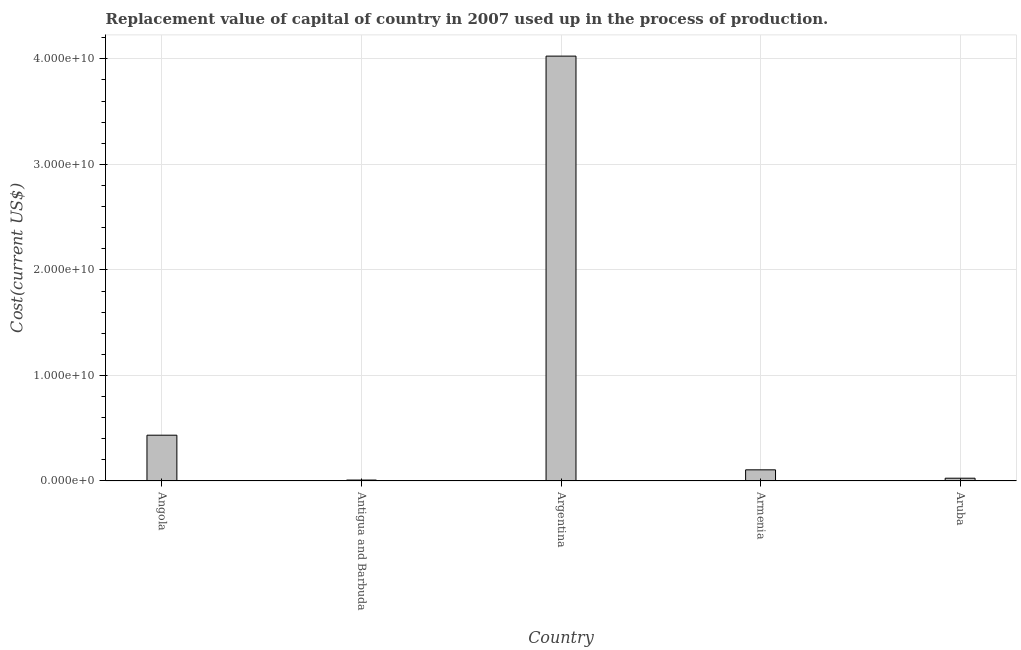What is the title of the graph?
Your answer should be compact. Replacement value of capital of country in 2007 used up in the process of production. What is the label or title of the Y-axis?
Your answer should be compact. Cost(current US$). What is the consumption of fixed capital in Armenia?
Offer a very short reply. 1.06e+09. Across all countries, what is the maximum consumption of fixed capital?
Your answer should be very brief. 4.03e+1. Across all countries, what is the minimum consumption of fixed capital?
Offer a very short reply. 8.85e+07. In which country was the consumption of fixed capital minimum?
Keep it short and to the point. Antigua and Barbuda. What is the sum of the consumption of fixed capital?
Make the answer very short. 4.60e+1. What is the difference between the consumption of fixed capital in Angola and Argentina?
Offer a very short reply. -3.59e+1. What is the average consumption of fixed capital per country?
Offer a terse response. 9.20e+09. What is the median consumption of fixed capital?
Ensure brevity in your answer.  1.06e+09. In how many countries, is the consumption of fixed capital greater than 8000000000 US$?
Offer a very short reply. 1. What is the ratio of the consumption of fixed capital in Argentina to that in Armenia?
Give a very brief answer. 38.05. What is the difference between the highest and the second highest consumption of fixed capital?
Provide a short and direct response. 3.59e+1. Is the sum of the consumption of fixed capital in Angola and Antigua and Barbuda greater than the maximum consumption of fixed capital across all countries?
Offer a very short reply. No. What is the difference between the highest and the lowest consumption of fixed capital?
Offer a very short reply. 4.02e+1. Are all the bars in the graph horizontal?
Your answer should be very brief. No. What is the difference between two consecutive major ticks on the Y-axis?
Keep it short and to the point. 1.00e+1. Are the values on the major ticks of Y-axis written in scientific E-notation?
Make the answer very short. Yes. What is the Cost(current US$) of Angola?
Your answer should be very brief. 4.34e+09. What is the Cost(current US$) in Antigua and Barbuda?
Your response must be concise. 8.85e+07. What is the Cost(current US$) of Argentina?
Your response must be concise. 4.03e+1. What is the Cost(current US$) in Armenia?
Provide a succinct answer. 1.06e+09. What is the Cost(current US$) of Aruba?
Offer a terse response. 2.63e+08. What is the difference between the Cost(current US$) in Angola and Antigua and Barbuda?
Your answer should be very brief. 4.25e+09. What is the difference between the Cost(current US$) in Angola and Argentina?
Provide a short and direct response. -3.59e+1. What is the difference between the Cost(current US$) in Angola and Armenia?
Your response must be concise. 3.28e+09. What is the difference between the Cost(current US$) in Angola and Aruba?
Make the answer very short. 4.08e+09. What is the difference between the Cost(current US$) in Antigua and Barbuda and Argentina?
Offer a very short reply. -4.02e+1. What is the difference between the Cost(current US$) in Antigua and Barbuda and Armenia?
Ensure brevity in your answer.  -9.70e+08. What is the difference between the Cost(current US$) in Antigua and Barbuda and Aruba?
Your response must be concise. -1.75e+08. What is the difference between the Cost(current US$) in Argentina and Armenia?
Your answer should be compact. 3.92e+1. What is the difference between the Cost(current US$) in Argentina and Aruba?
Your answer should be very brief. 4.00e+1. What is the difference between the Cost(current US$) in Armenia and Aruba?
Ensure brevity in your answer.  7.95e+08. What is the ratio of the Cost(current US$) in Angola to that in Antigua and Barbuda?
Give a very brief answer. 49.05. What is the ratio of the Cost(current US$) in Angola to that in Argentina?
Your response must be concise. 0.11. What is the ratio of the Cost(current US$) in Angola to that in Armenia?
Your answer should be compact. 4.1. What is the ratio of the Cost(current US$) in Angola to that in Aruba?
Make the answer very short. 16.47. What is the ratio of the Cost(current US$) in Antigua and Barbuda to that in Argentina?
Give a very brief answer. 0. What is the ratio of the Cost(current US$) in Antigua and Barbuda to that in Armenia?
Ensure brevity in your answer.  0.08. What is the ratio of the Cost(current US$) in Antigua and Barbuda to that in Aruba?
Provide a short and direct response. 0.34. What is the ratio of the Cost(current US$) in Argentina to that in Armenia?
Your answer should be compact. 38.05. What is the ratio of the Cost(current US$) in Argentina to that in Aruba?
Offer a very short reply. 152.81. What is the ratio of the Cost(current US$) in Armenia to that in Aruba?
Your response must be concise. 4.02. 